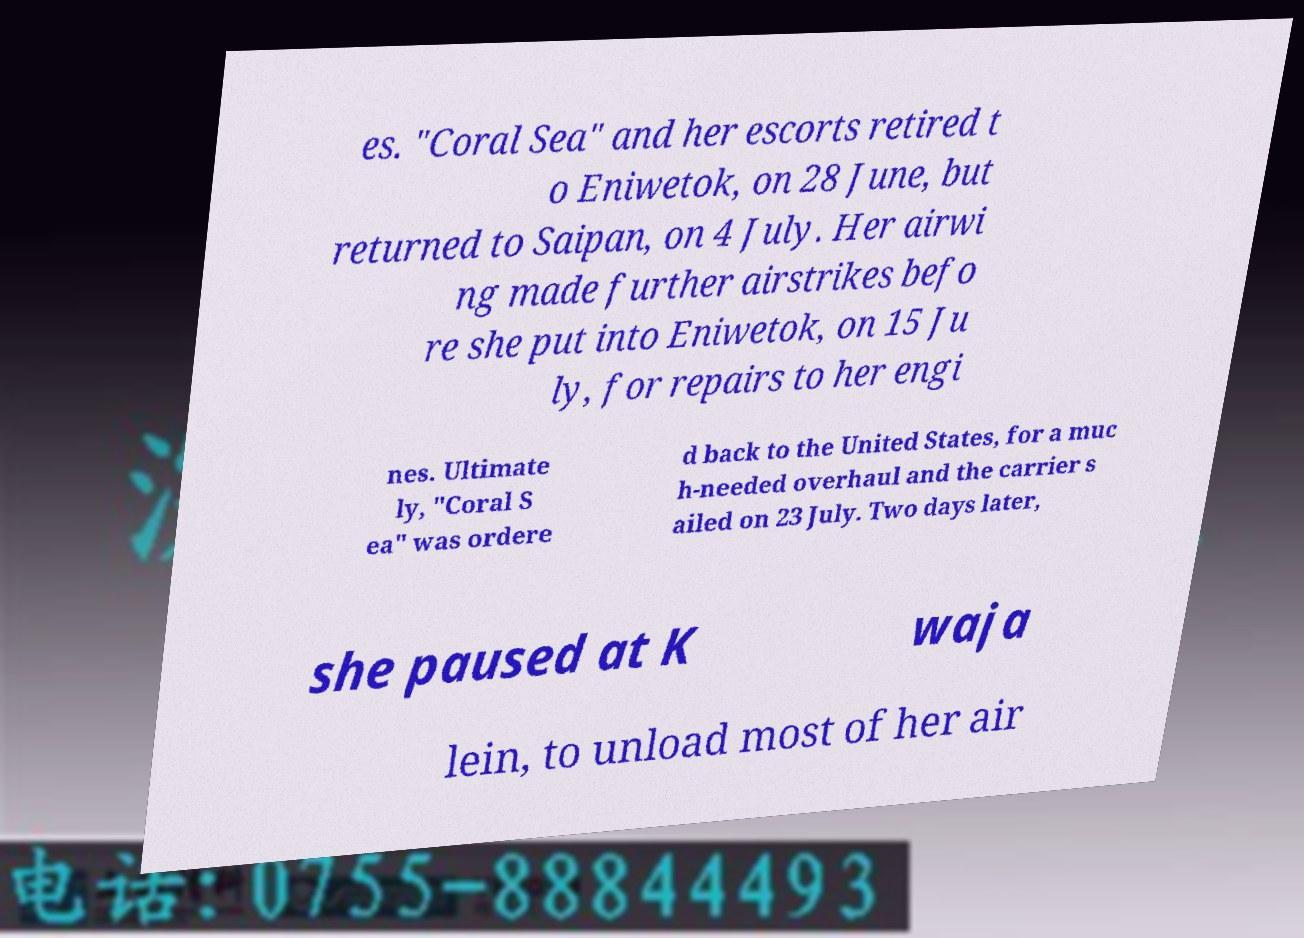Could you extract and type out the text from this image? es. "Coral Sea" and her escorts retired t o Eniwetok, on 28 June, but returned to Saipan, on 4 July. Her airwi ng made further airstrikes befo re she put into Eniwetok, on 15 Ju ly, for repairs to her engi nes. Ultimate ly, "Coral S ea" was ordere d back to the United States, for a muc h-needed overhaul and the carrier s ailed on 23 July. Two days later, she paused at K waja lein, to unload most of her air 